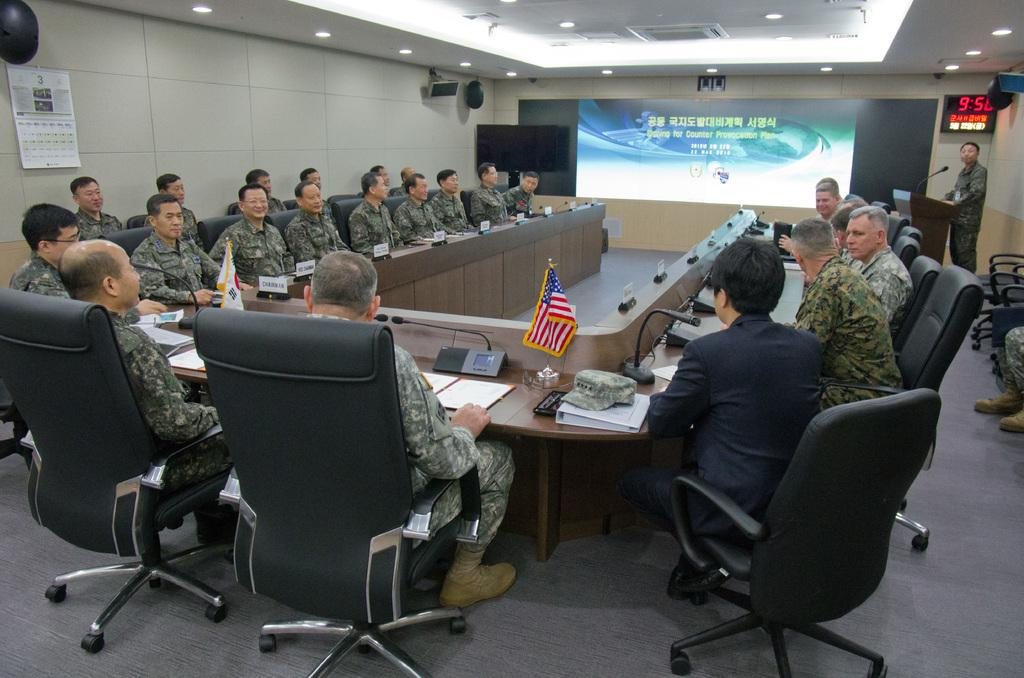What is the primary object featured on the wall in the image? There is a calendar on the wall in the image. What type of surface is visible in the image? There is a wall and a table visible in the image. What electronic device is present in the image? There is a screen in the image. How many people are sitting in the image? There are people sitting on chairs in the image. What items can be seen on the table in the image? There is a cap, a boom, a mic, and a phone on the table in the image. What type of alarm can be heard going off in the image? There is no alarm present or audible in the image. Can you see any waves in the image? There are no waves visible in the image. 